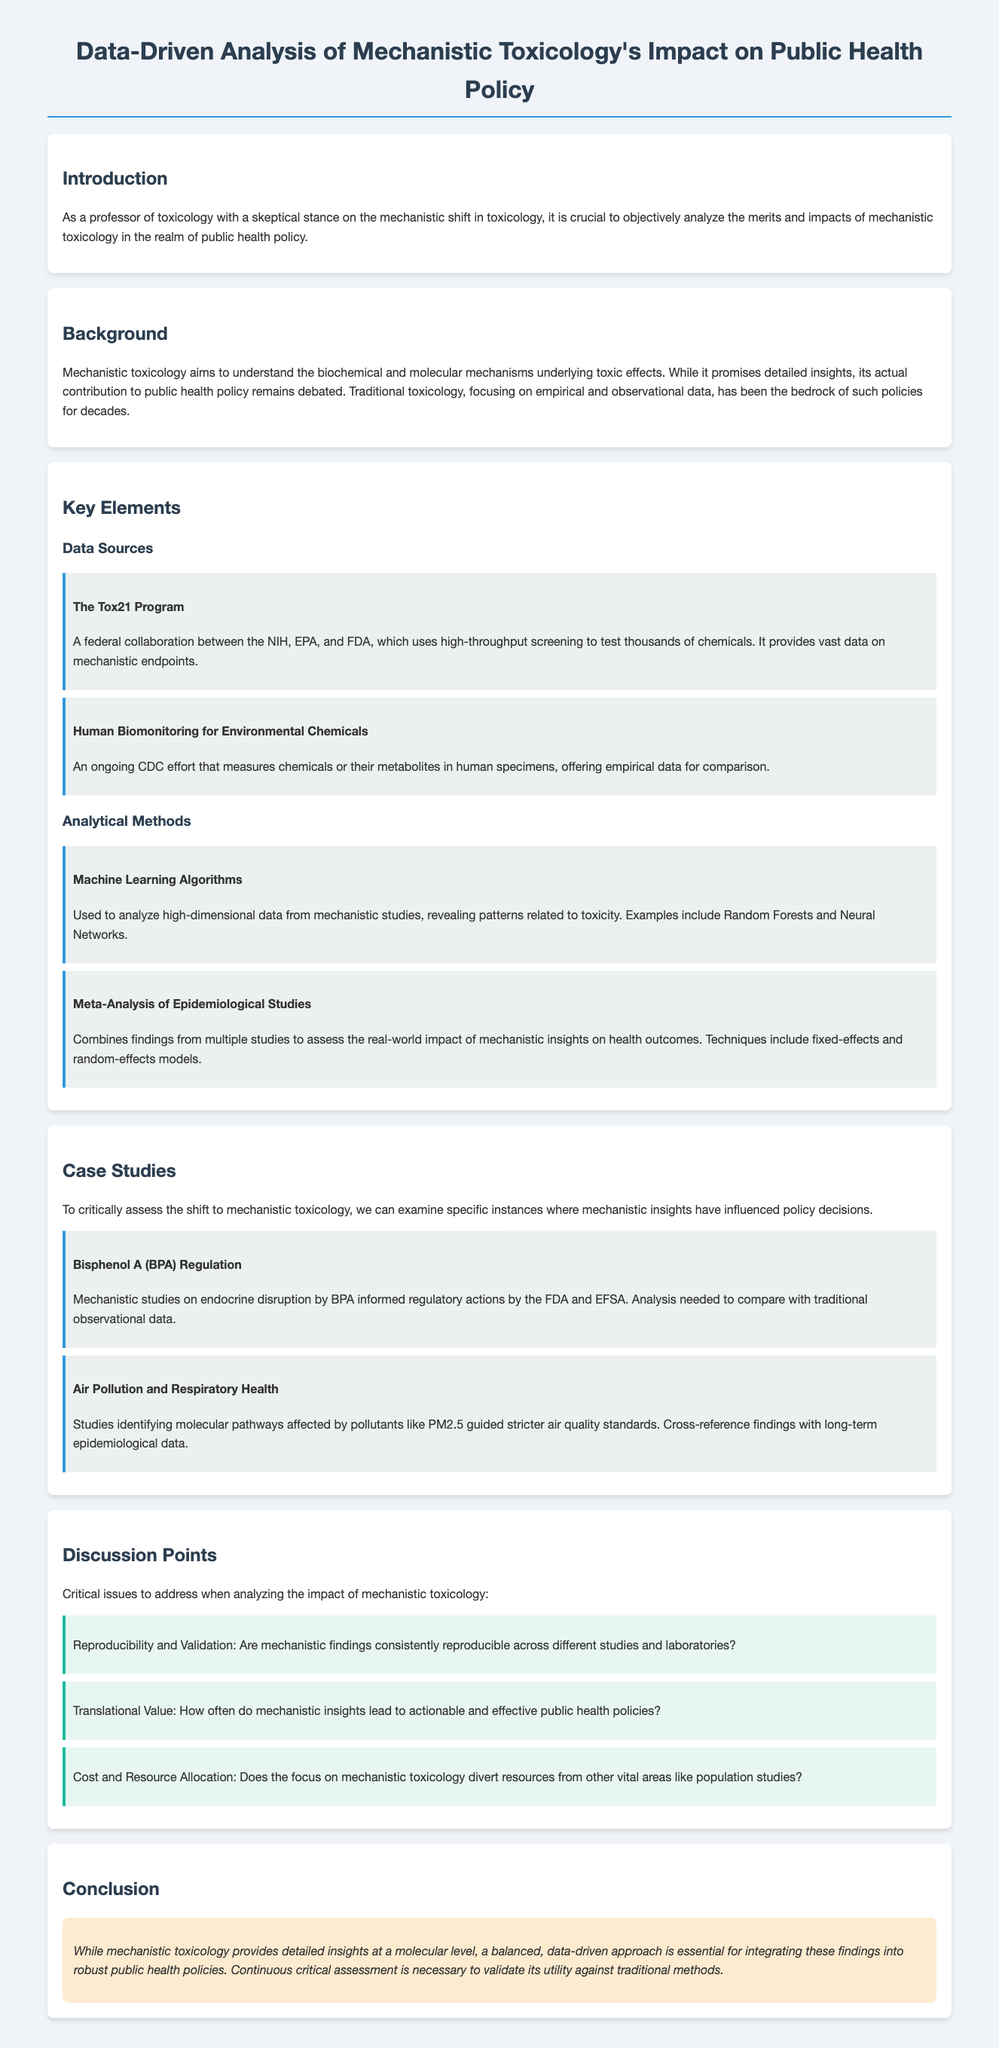What is the main topic of the document? The main topic is a data-driven analysis of mechanistic toxicology's impact on public health policy.
Answer: Data-driven analysis of mechanistic toxicology's impact on public health policy Who collaborates in the Tox21 Program? The Tox21 Program is a collaboration between the NIH, EPA, and FDA.
Answer: NIH, EPA, and FDA Which analytical method uses machine learning algorithms? Machine learning algorithms are utilized to analyze high-dimensional data from mechanistic studies.
Answer: Machine Learning Algorithms What is a critical issue regarding mechanistic findings mentioned in the discussion points? Reproducibility and validation of mechanistic findings are highlighted as a critical issue.
Answer: Reproducibility and Validation How does the document suggest comparing mechanistic insights? The document suggests comparing mechanistic insights with traditional observational data.
Answer: Traditional observational data 